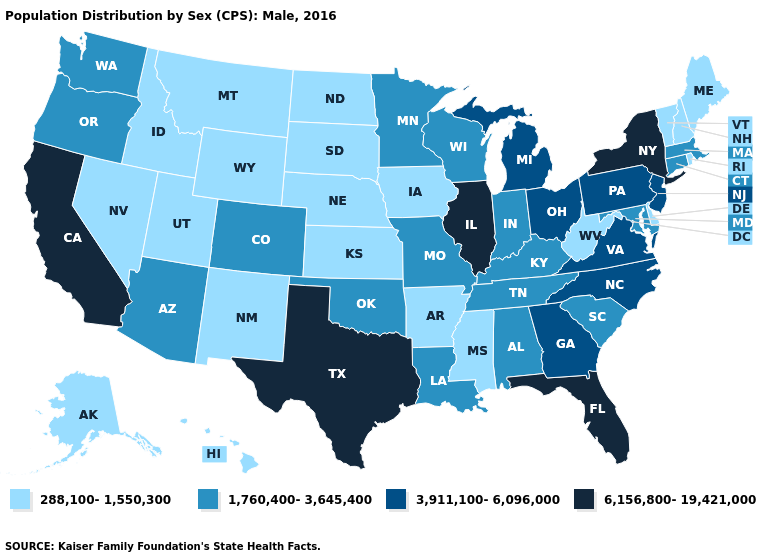Name the states that have a value in the range 6,156,800-19,421,000?
Write a very short answer. California, Florida, Illinois, New York, Texas. What is the highest value in the USA?
Short answer required. 6,156,800-19,421,000. Does Alaska have a lower value than Louisiana?
Keep it brief. Yes. Among the states that border Oregon , does Idaho have the lowest value?
Keep it brief. Yes. Name the states that have a value in the range 288,100-1,550,300?
Quick response, please. Alaska, Arkansas, Delaware, Hawaii, Idaho, Iowa, Kansas, Maine, Mississippi, Montana, Nebraska, Nevada, New Hampshire, New Mexico, North Dakota, Rhode Island, South Dakota, Utah, Vermont, West Virginia, Wyoming. Which states have the highest value in the USA?
Be succinct. California, Florida, Illinois, New York, Texas. Does Montana have a higher value than Tennessee?
Be succinct. No. Is the legend a continuous bar?
Answer briefly. No. What is the highest value in the South ?
Quick response, please. 6,156,800-19,421,000. Name the states that have a value in the range 6,156,800-19,421,000?
Answer briefly. California, Florida, Illinois, New York, Texas. Does New Mexico have a lower value than Pennsylvania?
Concise answer only. Yes. Does Montana have the lowest value in the West?
Keep it brief. Yes. Does Arkansas have the highest value in the USA?
Short answer required. No. Name the states that have a value in the range 1,760,400-3,645,400?
Keep it brief. Alabama, Arizona, Colorado, Connecticut, Indiana, Kentucky, Louisiana, Maryland, Massachusetts, Minnesota, Missouri, Oklahoma, Oregon, South Carolina, Tennessee, Washington, Wisconsin. Does Ohio have the highest value in the USA?
Answer briefly. No. 